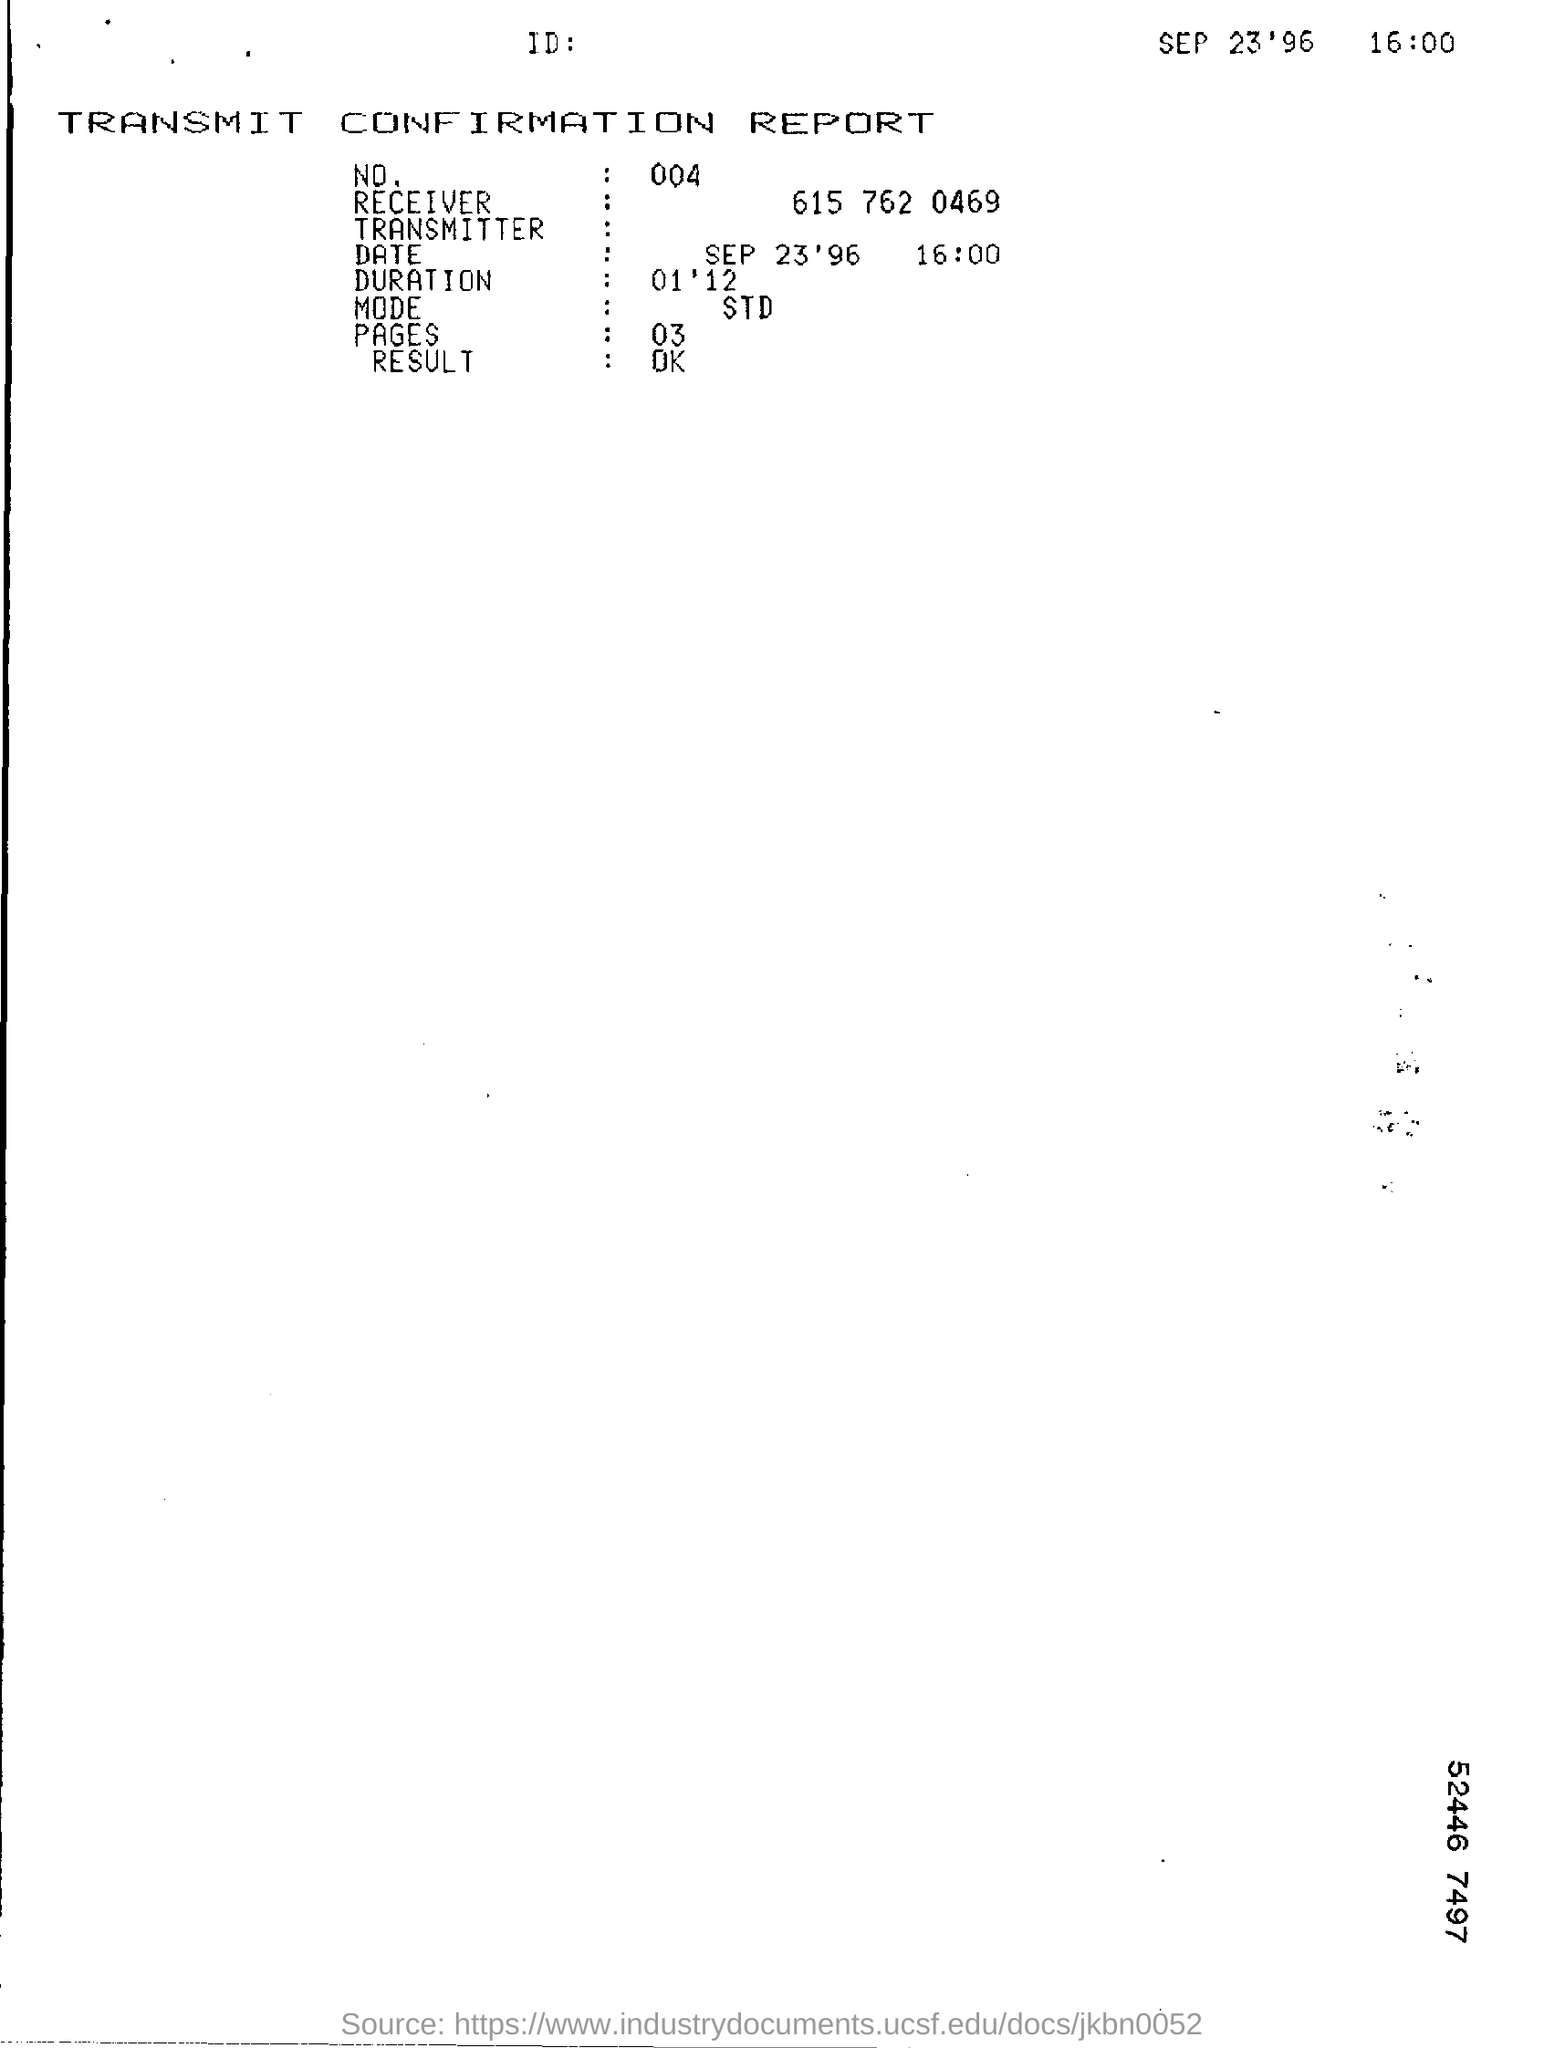Can you tell me more about the historical context of this type of report? Certainly! The image shows a TRANSMIT CONFIRMATION REPORT from 1996, which was typically generated by a fax machine to confirm the successful sending of documents. Before the widespread use of email, fax was a primary method for instant document transmission in business and personal communication. Such reports were crucial for verifying that the intended recipient received the document without any issues.  What technical details can you infer from the report? The report indicates a 'STD' mode, which likely stands for standard transmission, signifying that no specific high-priority or encryption methods were used. The duration of '01'12'' suggests the transmission took one minute and twelve seconds, which gives an idea about the speed and efficiency of the machine used. The three pages sent in this time frame also suggest a relatively fast transmission for that period. 